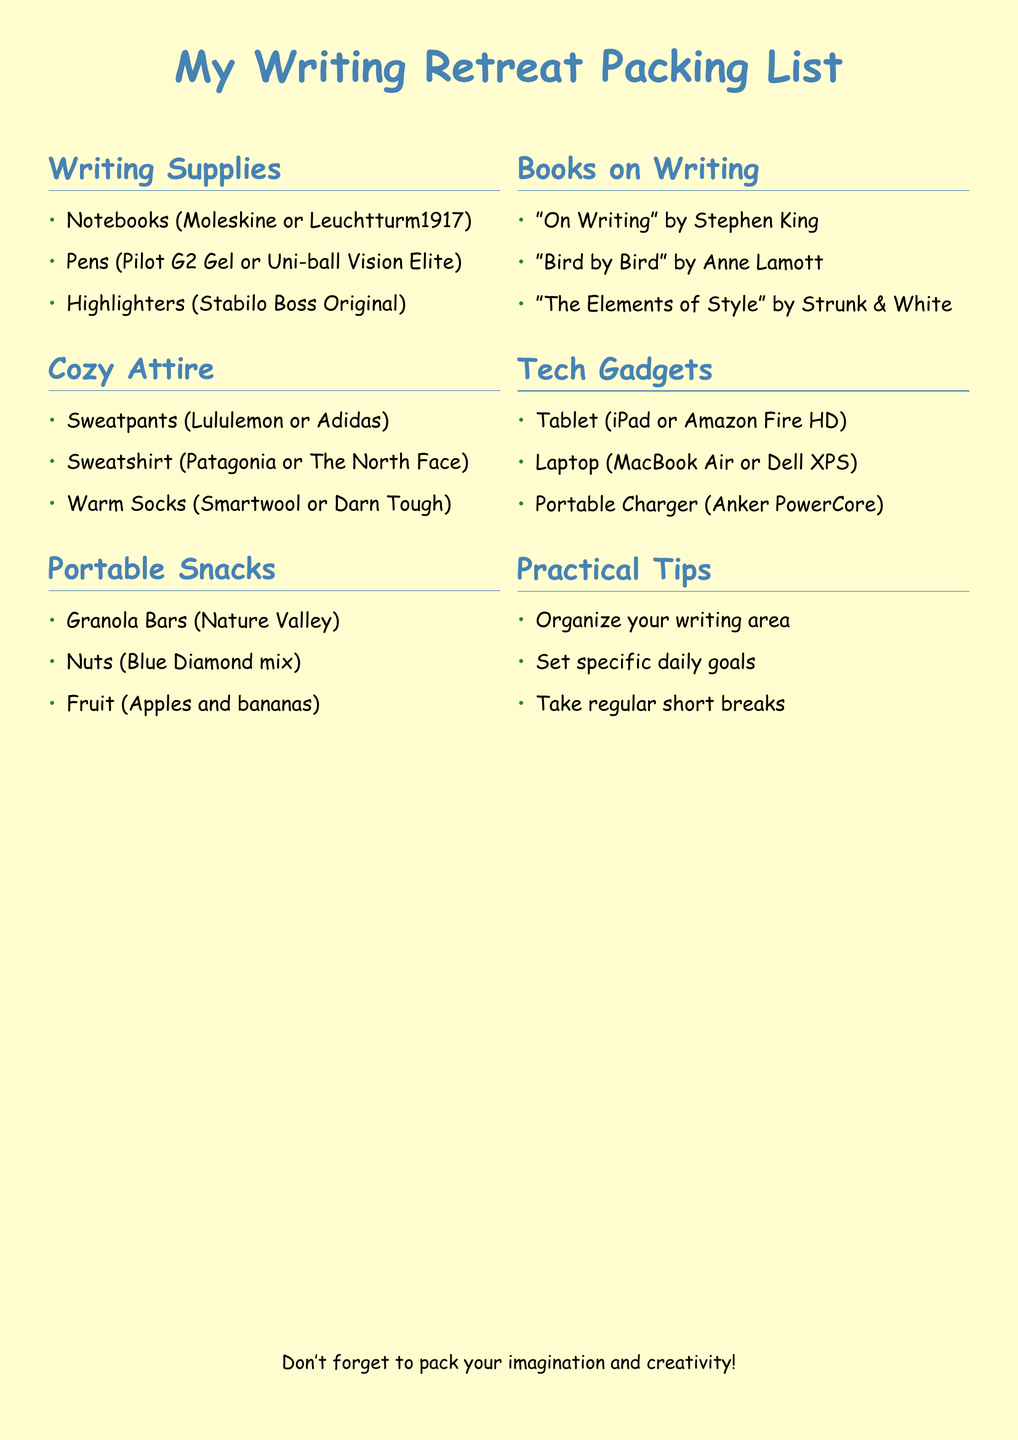What are the recommended notebooks? The recommended notebooks listed in the document are Moleskine or Leuchtturm1917.
Answer: Moleskine or Leuchtturm1917 Which author wrote "Bird by Bird"? The document lists "Bird by Bird" as a book on writing and attributes it to Anne Lamott.
Answer: Anne Lamott What type of sweatpants are suggested? The document suggests sweatpants from Lululemon or Adidas as part of cozy attire.
Answer: Lululemon or Adidas How many portable snacks are listed? The document lists three portable snacks: Granola Bars, Nuts, and Fruit.
Answer: Three What is a practical tip for the writing retreat? One of the practical tips mentioned is to set specific daily goals.
Answer: Set specific daily goals Which tech gadget is a portable charger? The document identifies the Anker PowerCore as the portable charger in the tech gadgets section.
Answer: Anker PowerCore 